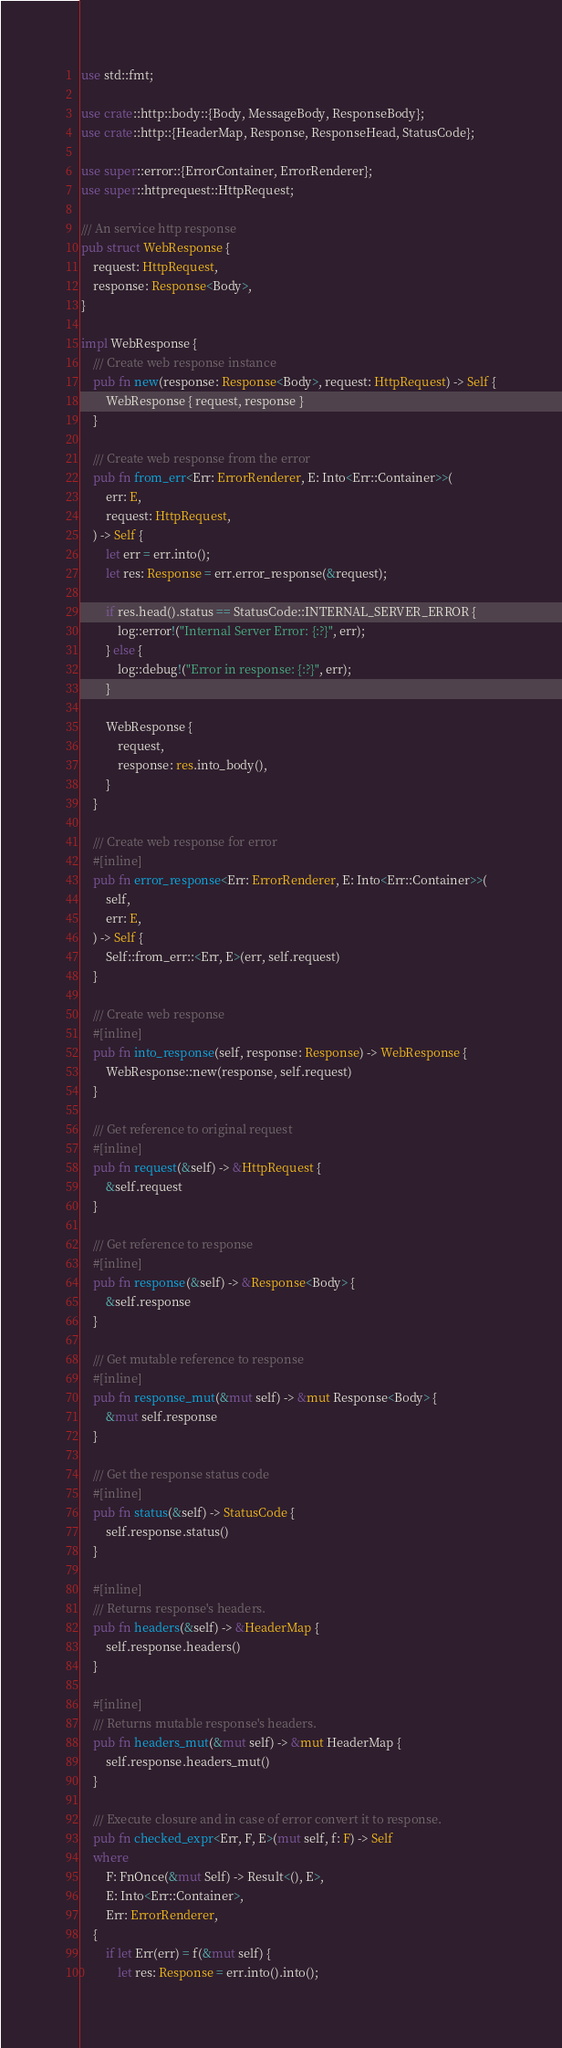<code> <loc_0><loc_0><loc_500><loc_500><_Rust_>use std::fmt;

use crate::http::body::{Body, MessageBody, ResponseBody};
use crate::http::{HeaderMap, Response, ResponseHead, StatusCode};

use super::error::{ErrorContainer, ErrorRenderer};
use super::httprequest::HttpRequest;

/// An service http response
pub struct WebResponse {
    request: HttpRequest,
    response: Response<Body>,
}

impl WebResponse {
    /// Create web response instance
    pub fn new(response: Response<Body>, request: HttpRequest) -> Self {
        WebResponse { request, response }
    }

    /// Create web response from the error
    pub fn from_err<Err: ErrorRenderer, E: Into<Err::Container>>(
        err: E,
        request: HttpRequest,
    ) -> Self {
        let err = err.into();
        let res: Response = err.error_response(&request);

        if res.head().status == StatusCode::INTERNAL_SERVER_ERROR {
            log::error!("Internal Server Error: {:?}", err);
        } else {
            log::debug!("Error in response: {:?}", err);
        }

        WebResponse {
            request,
            response: res.into_body(),
        }
    }

    /// Create web response for error
    #[inline]
    pub fn error_response<Err: ErrorRenderer, E: Into<Err::Container>>(
        self,
        err: E,
    ) -> Self {
        Self::from_err::<Err, E>(err, self.request)
    }

    /// Create web response
    #[inline]
    pub fn into_response(self, response: Response) -> WebResponse {
        WebResponse::new(response, self.request)
    }

    /// Get reference to original request
    #[inline]
    pub fn request(&self) -> &HttpRequest {
        &self.request
    }

    /// Get reference to response
    #[inline]
    pub fn response(&self) -> &Response<Body> {
        &self.response
    }

    /// Get mutable reference to response
    #[inline]
    pub fn response_mut(&mut self) -> &mut Response<Body> {
        &mut self.response
    }

    /// Get the response status code
    #[inline]
    pub fn status(&self) -> StatusCode {
        self.response.status()
    }

    #[inline]
    /// Returns response's headers.
    pub fn headers(&self) -> &HeaderMap {
        self.response.headers()
    }

    #[inline]
    /// Returns mutable response's headers.
    pub fn headers_mut(&mut self) -> &mut HeaderMap {
        self.response.headers_mut()
    }

    /// Execute closure and in case of error convert it to response.
    pub fn checked_expr<Err, F, E>(mut self, f: F) -> Self
    where
        F: FnOnce(&mut Self) -> Result<(), E>,
        E: Into<Err::Container>,
        Err: ErrorRenderer,
    {
        if let Err(err) = f(&mut self) {
            let res: Response = err.into().into();</code> 